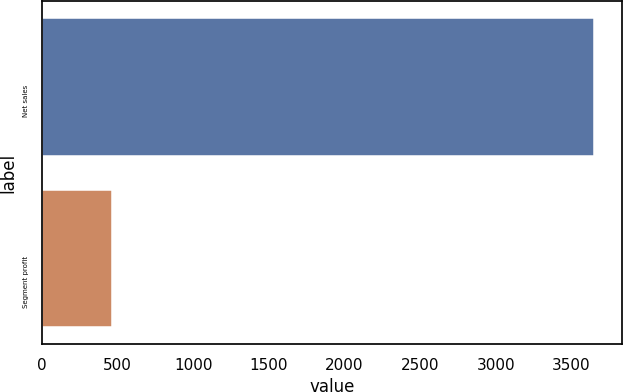Convert chart to OTSL. <chart><loc_0><loc_0><loc_500><loc_500><bar_chart><fcel>Net sales<fcel>Segment profit<nl><fcel>3650<fcel>461<nl></chart> 